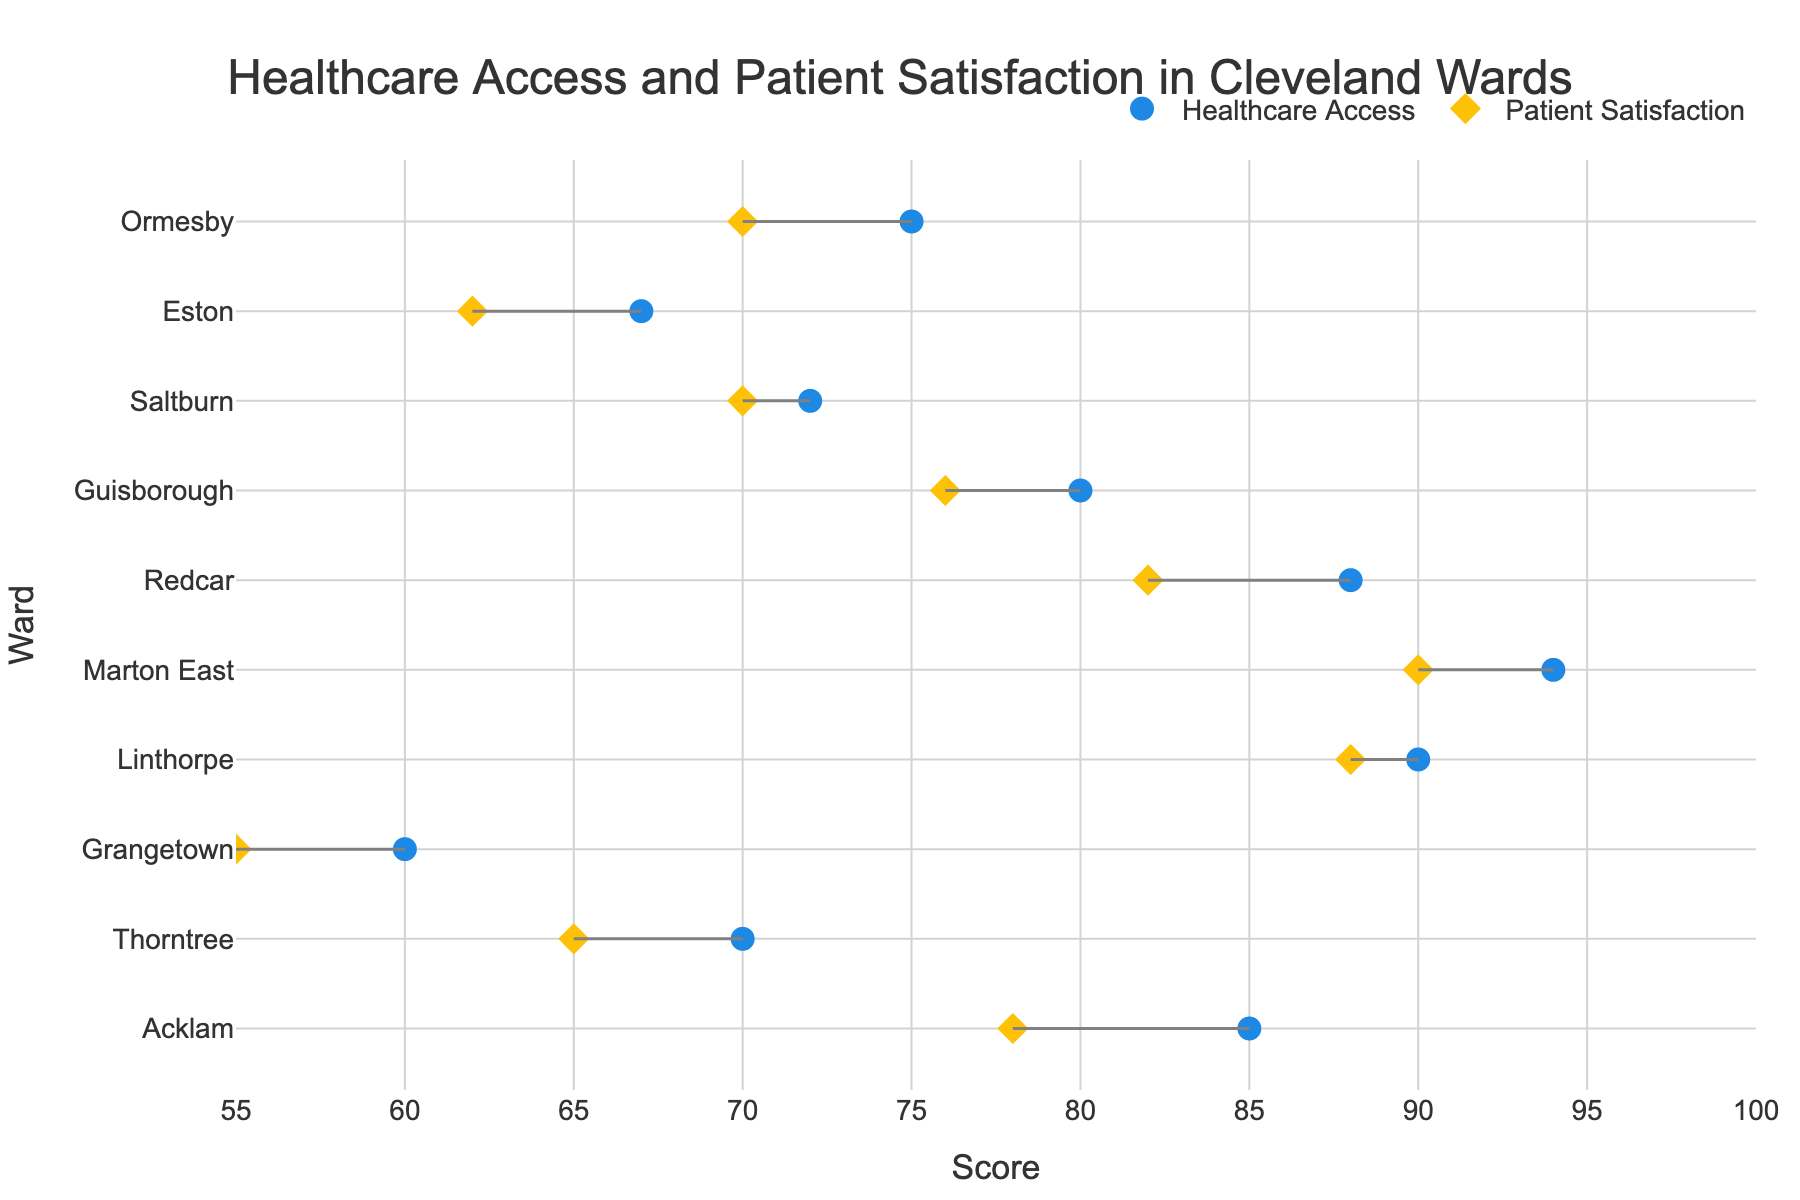How many wards in Cleveland are compared in the plot? Count the number of different wards listed on the y-axis. There are 10 wards displayed in the plot.
Answer: 10 Which ward has the highest Healthcare Access score? Look at the dots on the plot corresponding to Healthcare Access and find the highest value. Marton East has the highest Healthcare Access score with a score of 94.
Answer: Marton East What is the Patient Satisfaction score for Acklam ward? Identify the diamond marker corresponding to Acklam. The Patient Satisfaction score for Acklam is 78.
Answer: 78 Which wards have equal Patient Satisfaction scores? Look for wards where the diamond markers align on the same Patient Satisfaction score. Ormesby and Saltburn both have a Patient Satisfaction score of 70.
Answer: Ormesby and Saltburn In which ward is the gap between Healthcare Access and Patient Satisfaction the largest? Measure the horizontal distance between the circle and diamond markers for each ward and find the largest gap. Thorntree has the largest gap of 5 points between Healthcare Access (70) and Patient Satisfaction (65).
Answer: Thorntree What is the difference in Patient Satisfaction scores between Linthorpe and Grangetown? Subtract the Patient Satisfaction score of Grangetown (55) from that of Linthorpe (88). The difference is 88 - 55 = 33.
Answer: 33 Which ward shows the smallest gap between Healthcare Access and Patient Satisfaction? Identify the smallest horizontal distance between the circle and diamond markers. Linthorpe shows the smallest gap, with Healthcare Access at 90 and Patient Satisfaction at 88, resulting in a gap of 2.
Answer: Linthorpe How many wards have a Patient Satisfaction score above 75? Count the number of wards where the Patient Satisfaction score (diamond) is greater than 75. There are 5 wards: Acklam, Linthorpe, Marton East, Redcar, and Guisborough.
Answer: 5 Are there any wards where both Healthcare Access and Patient Satisfaction scores are below 70? Check for wards where both the circle and diamond markers fall below the 70 mark. Only Grangetown meets this criterion, with Healthcare Access of 60 and Patient Satisfaction of 55.
Answer: Grangetown Which ward has the lowest Patient Satisfaction score? Locate the diamond marker with the lowest value on the plot. Grangetown has the lowest Patient Satisfaction score with a value of 55.
Answer: Grangetown 